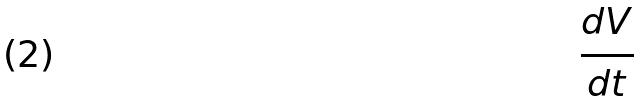<formula> <loc_0><loc_0><loc_500><loc_500>\frac { d V } { d t }</formula> 